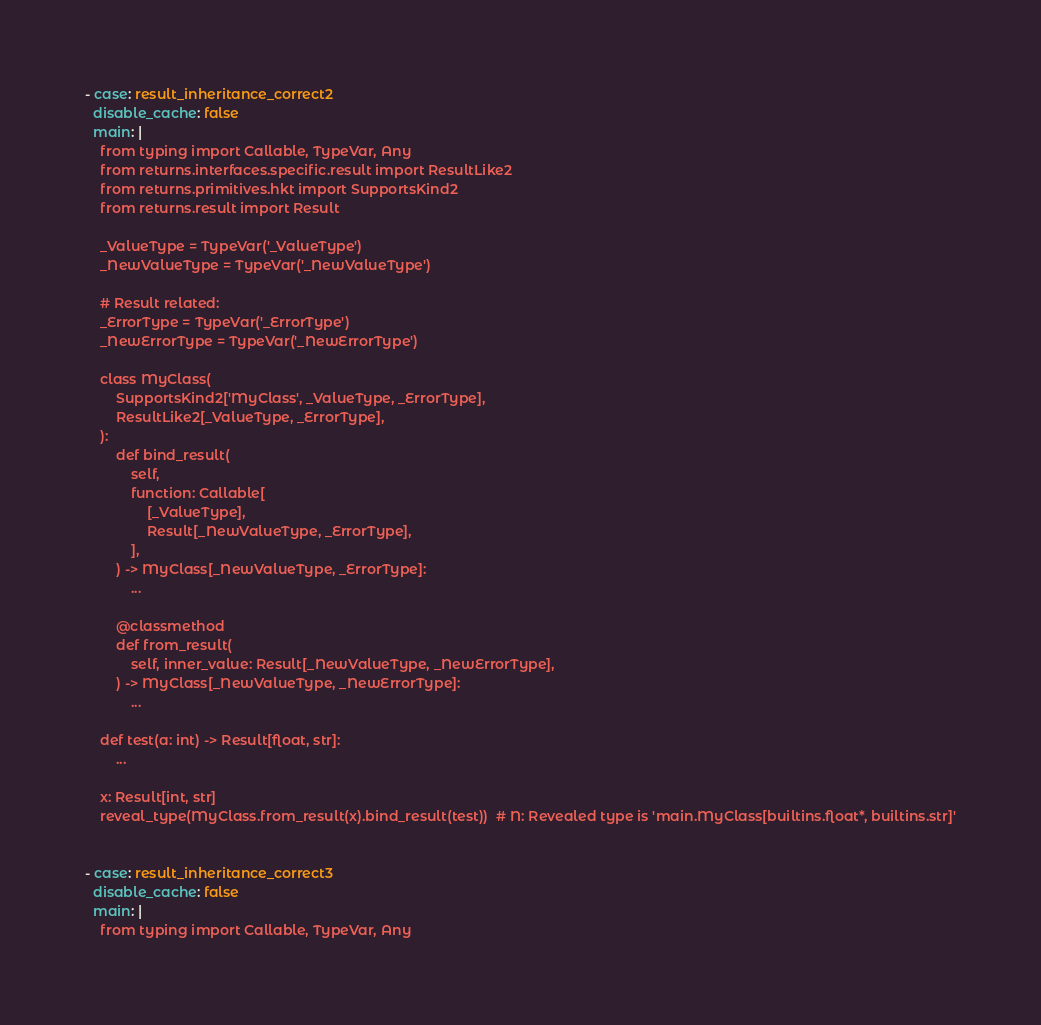Convert code to text. <code><loc_0><loc_0><loc_500><loc_500><_YAML_>- case: result_inheritance_correct2
  disable_cache: false
  main: |
    from typing import Callable, TypeVar, Any
    from returns.interfaces.specific.result import ResultLike2
    from returns.primitives.hkt import SupportsKind2
    from returns.result import Result

    _ValueType = TypeVar('_ValueType')
    _NewValueType = TypeVar('_NewValueType')

    # Result related:
    _ErrorType = TypeVar('_ErrorType')
    _NewErrorType = TypeVar('_NewErrorType')

    class MyClass(
        SupportsKind2['MyClass', _ValueType, _ErrorType],
        ResultLike2[_ValueType, _ErrorType],
    ):
        def bind_result(
            self,
            function: Callable[
                [_ValueType],
                Result[_NewValueType, _ErrorType],
            ],
        ) -> MyClass[_NewValueType, _ErrorType]:
            ...

        @classmethod
        def from_result(
            self, inner_value: Result[_NewValueType, _NewErrorType],
        ) -> MyClass[_NewValueType, _NewErrorType]:
            ...

    def test(a: int) -> Result[float, str]:
        ...

    x: Result[int, str]
    reveal_type(MyClass.from_result(x).bind_result(test))  # N: Revealed type is 'main.MyClass[builtins.float*, builtins.str]'


- case: result_inheritance_correct3
  disable_cache: false
  main: |
    from typing import Callable, TypeVar, Any</code> 